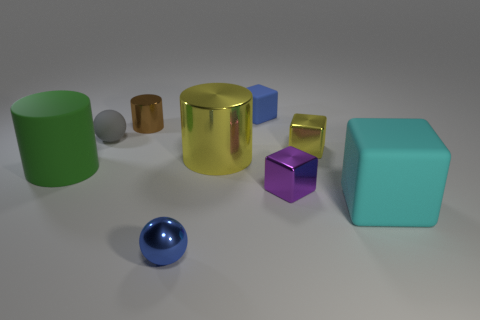What number of rubber objects are to the right of the tiny brown object and in front of the tiny gray thing?
Offer a terse response. 1. How many large things have the same material as the tiny purple cube?
Provide a succinct answer. 1. There is a green matte cylinder that is left of the ball on the right side of the brown shiny object; what size is it?
Offer a terse response. Large. Are there any tiny blue objects that have the same shape as the tiny purple metal object?
Offer a very short reply. Yes. Does the cyan rubber cube that is in front of the purple metallic block have the same size as the metal block in front of the tiny yellow thing?
Provide a short and direct response. No. Is the number of large cylinders to the left of the large yellow metallic cylinder less than the number of matte things that are to the right of the tiny gray sphere?
Provide a succinct answer. Yes. There is a tiny cube that is the same color as the small shiny ball; what is its material?
Offer a very short reply. Rubber. What color is the small shiny block that is in front of the big yellow metallic thing?
Keep it short and to the point. Purple. Is the color of the small metal sphere the same as the tiny rubber block?
Provide a succinct answer. Yes. What number of blue metal balls are on the left side of the big matte thing on the right side of the big object that is to the left of the brown cylinder?
Offer a terse response. 1. 